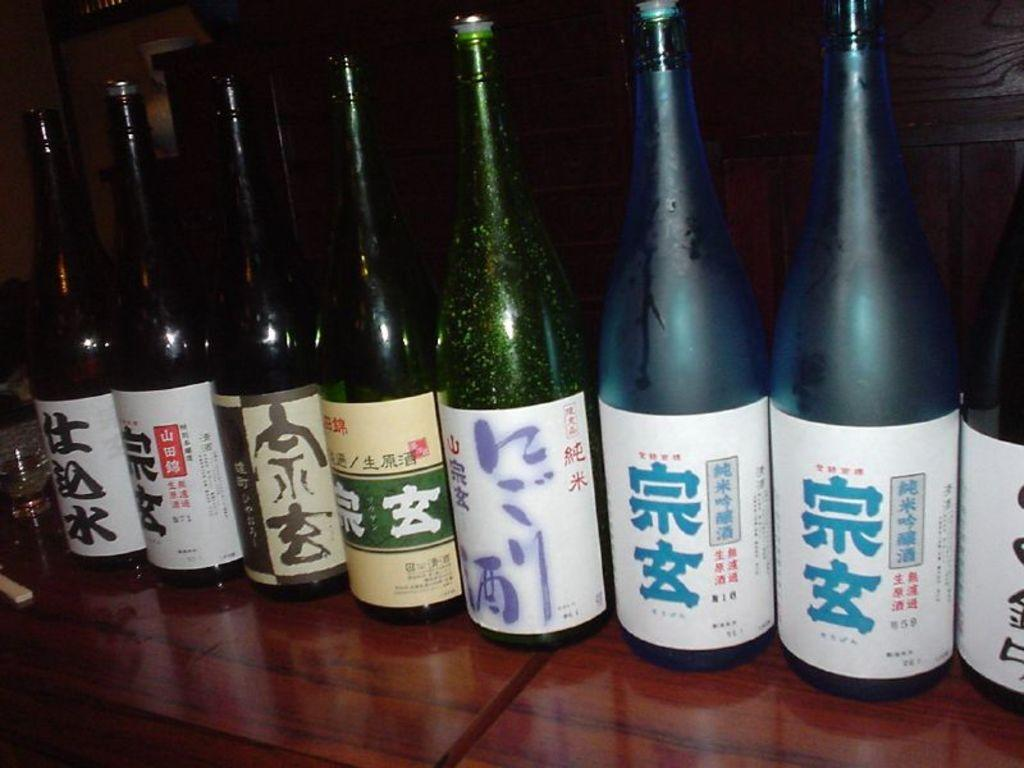What is the main subject of the image? The main subject of the image is a group of wine bottles. What can be seen on the wine bottles? The wine bottles have labels on them. Where are the wine bottles located? The wine bottles are on a table. What type of lip can be seen on the wine bottles in the image? There is no lip present on the wine bottles in the image; they have labels instead. 